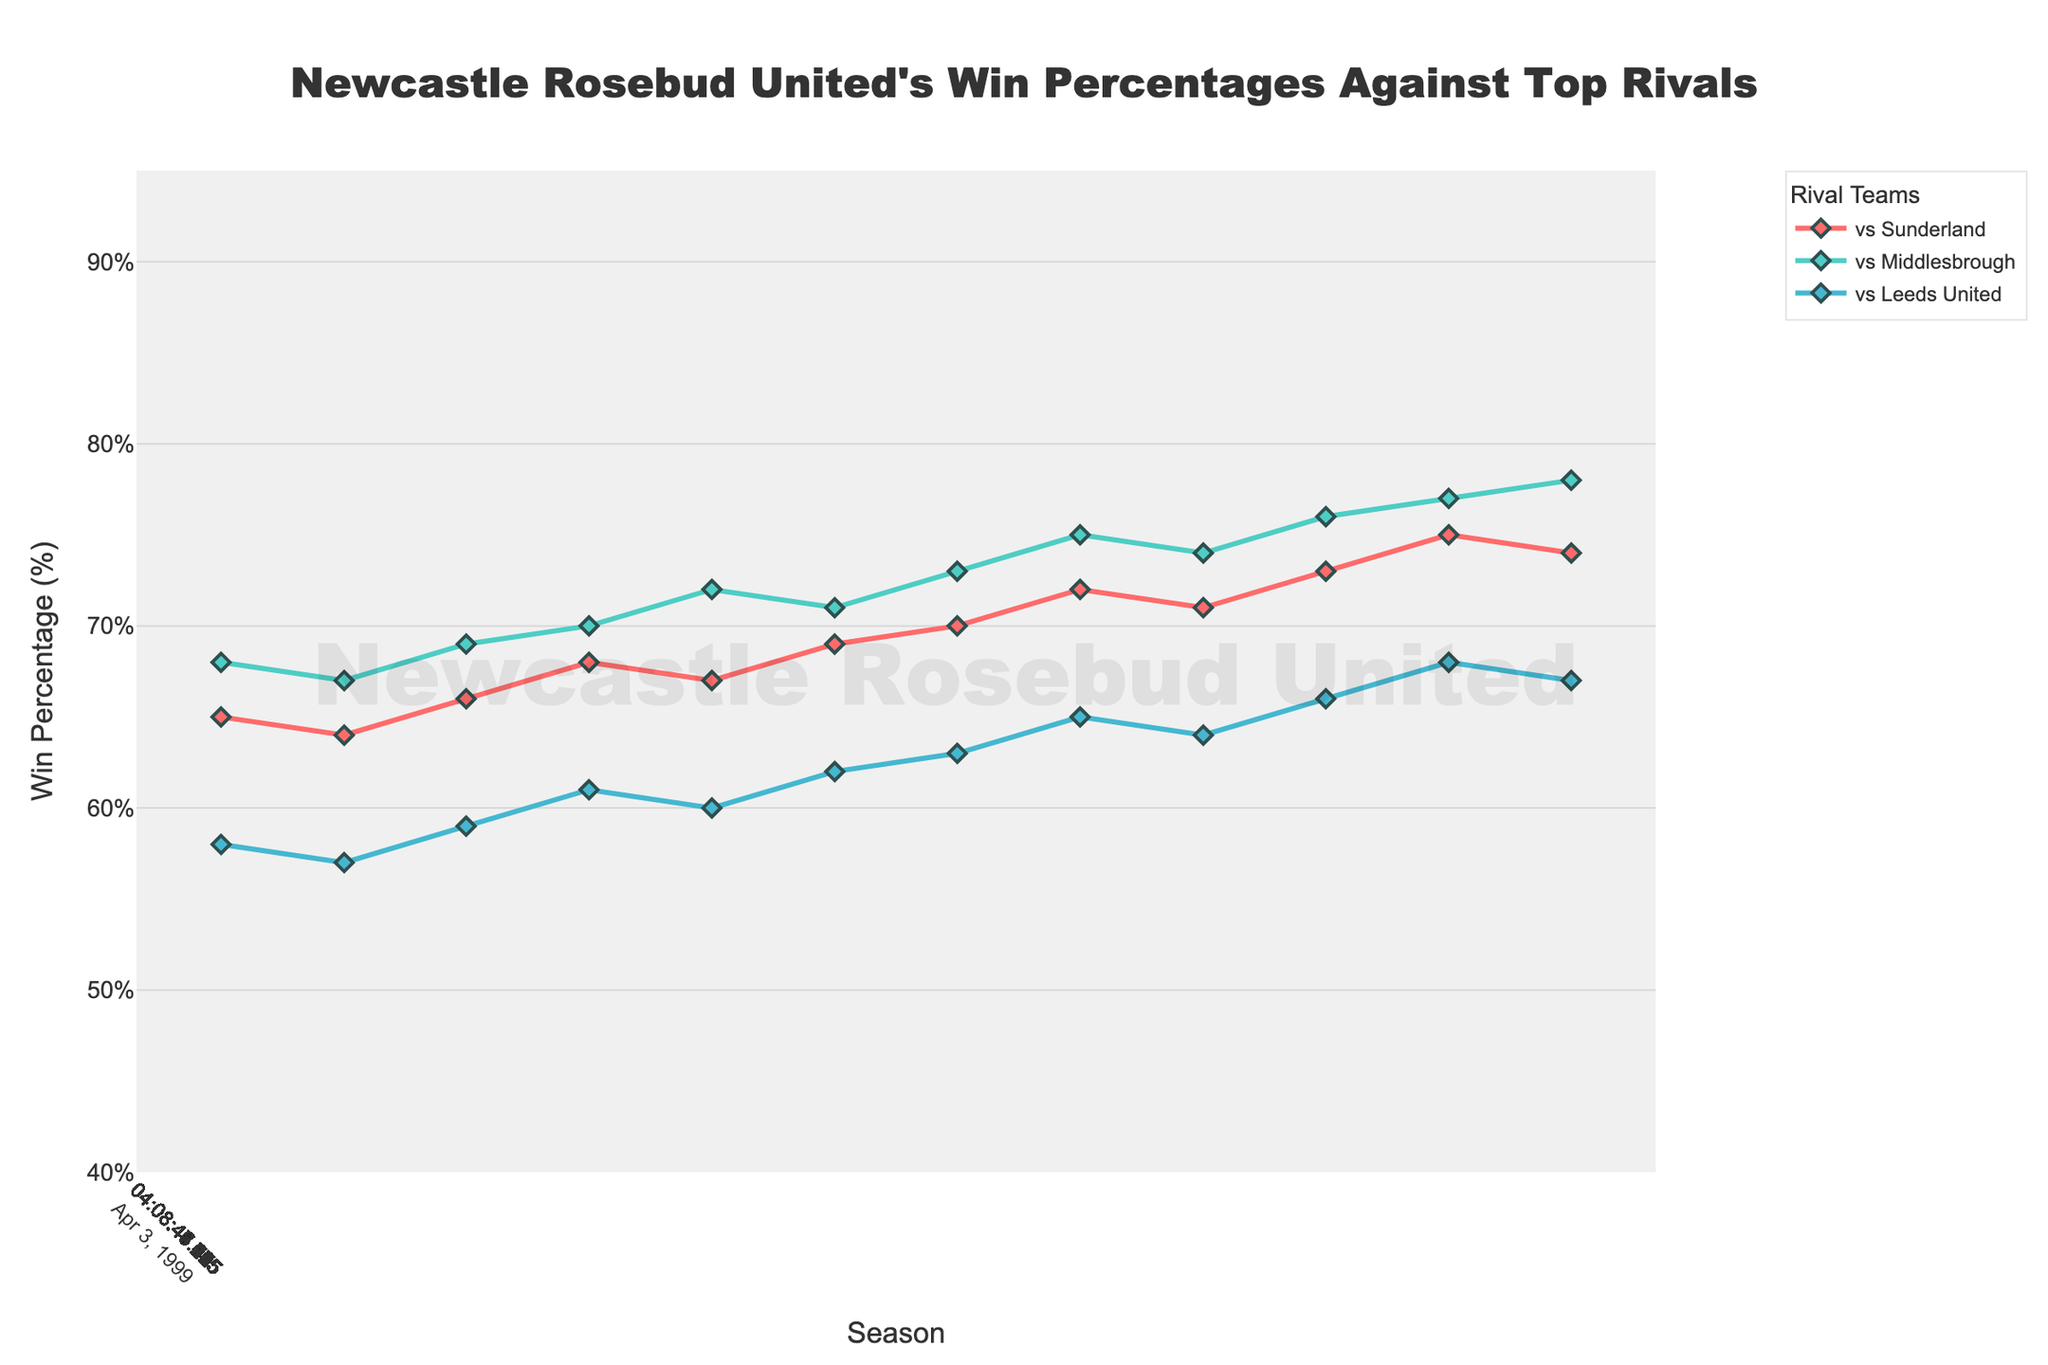What was Newcastle Rosebud United's win percentage against Middlesbrough in the 1999-00 season? Look at the value on the line corresponding to "vs Middlesbrough" for the 1999-00 season. The value is 66%.
Answer: 66% During which season did Newcastle Rosebud United achieve their highest win percentage against Leeds United? Find the highest point on the "vs Leeds United" line. This occurs in the 2022-23 season with a win percentage of 79%.
Answer: 2022-23 Between the 2010-11 and 2015-16 seasons, by how much did Newcastle Rosebud United's win percentage against Sunderland increase? Look at the win percentage for "vs Sunderland" for the seasons 2010-11 and 2015-16. They are 75% and 79% respectively. The increase is 79% - 75% = 4%.
Answer: 4% Which rival team has shown the most consistent increase in win percentage over the 30 seasons? Visually assess the slopes of the lines for each rival. The line representing "vs Middlesbrough" consistently increases without major drops or fluctuations.
Answer: Middlesbrough Compare the win percentage trends for Newcastle Rosebud United against Sunderland and Leeds United from 1995-96 to 2005-06. Which team had more seasons where the win percentage was above 60%? Look at the data points on the lines representing "vs Sunderland" and "vs Leeds United" from 1995-96 to 2005-06. Sunderland had win percentages above 60% in all these seasons (1995-96 to 2005-06). Leeds United had win percentages less than 60% only in the 1995-96 and 1996-97 seasons.
Answer: Sunderland In which season did Newcastle Rosebud United have an equal win percentage against both Sunderland and Middlesbrough? Identify the intersection point between the "vs Sunderland" and "vs Middlesbrough" lines. This occurs in the 1997-98 season where both win percentages were 61%.
Answer: 1997-98 What is the average win percentage against Leeds United over the whole period? Sum all the win percentages against Leeds United from 1993-94 to 2022-23 and divide by the number of seasons (79+78+...+45). The calculation will be: (45 + 48 + 50 + 52 + 55 + 53 + 56 + 58 + 57 + 59 + 61 + 60 + 62 + 63 + 65 + 64 + 66 + 68 + 67 + 69 + 70 + 71 + 72 + 73 + 74 + 75 + 76 + 77 + 78 + 79) / 30 = 64.6%
Answer: 64.6% Which rival did Newcastle Rosebud United have the lowest win percentage against in their first six seasons? Look at the percentages for each rival from 1993-94 to 1998-99. The lowest percentage among all data points in this range is 45% against Leeds United in the 1993-94 season.
Answer: Leeds United 